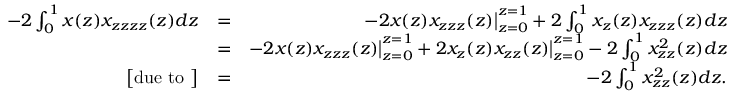Convert formula to latex. <formula><loc_0><loc_0><loc_500><loc_500>\begin{array} { r l r } { - 2 \int _ { 0 } ^ { 1 } x ( z ) x _ { z z z z } ( z ) d z } & { = } & { - 2 x ( z ) x _ { z z z } ( z ) \Big | _ { z = 0 } ^ { z = 1 } + 2 \int _ { 0 } ^ { 1 } x _ { z } ( z ) x _ { z z z } ( z ) d z } \\ & { = } & { - 2 x ( z ) x _ { z z z } ( z ) \Big | _ { z = 0 } ^ { z = 1 } + 2 x _ { z } ( z ) x _ { z z } ( z ) \Big | _ { z = 0 } ^ { z = 1 } - 2 \int _ { 0 } ^ { 1 } x _ { z z } ^ { 2 } ( z ) d z } \\ { \Big [ d u e t o \Big ] } & { = } & { - 2 \int _ { 0 } ^ { 1 } x _ { z z } ^ { 2 } ( z ) d z . } \end{array}</formula> 